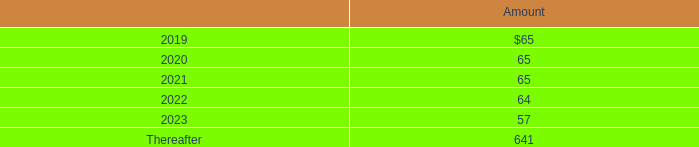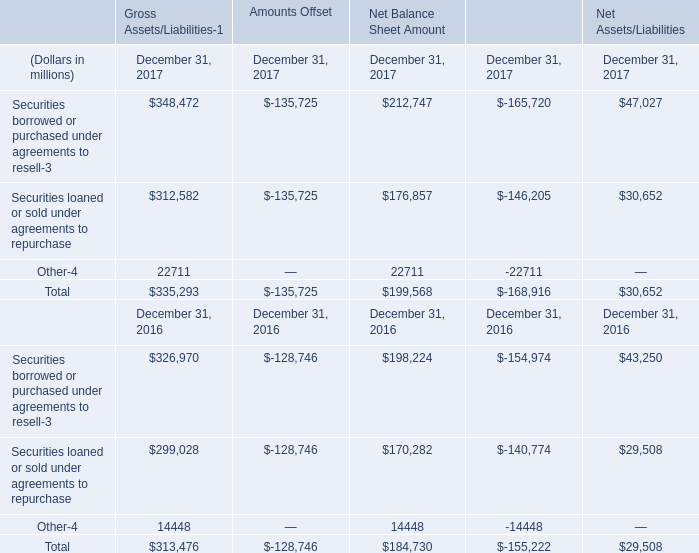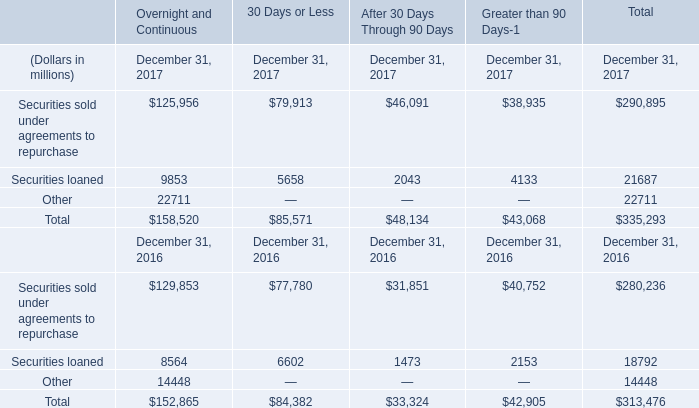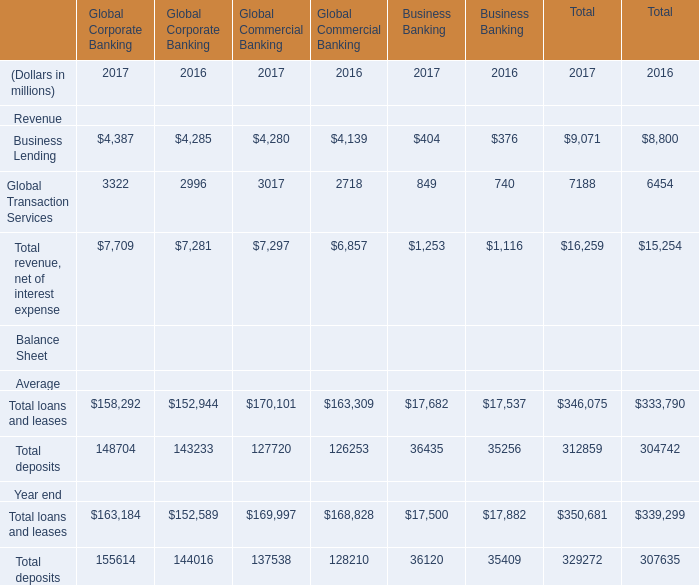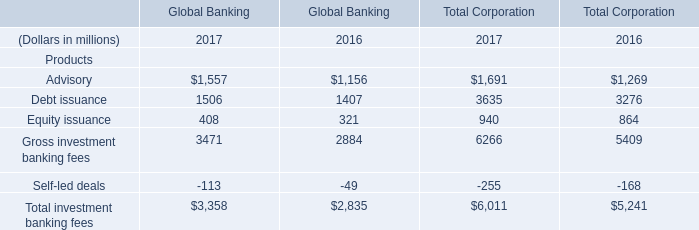What is the sum of Business Lending of Global Commercial Banking 2016, and Other of Financial Instruments December 31, 2017 ? 
Computations: (4139.0 + 14448.0)
Answer: 18587.0. 